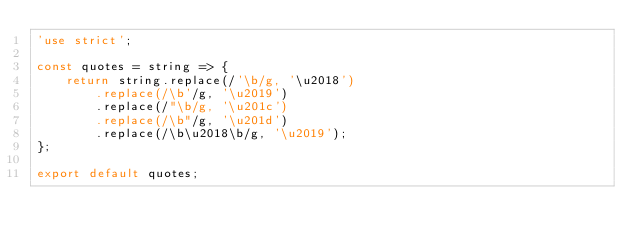<code> <loc_0><loc_0><loc_500><loc_500><_JavaScript_>'use strict';

const quotes = string => {
	return string.replace(/'\b/g, '\u2018')
		.replace(/\b'/g, '\u2019')
		.replace(/"\b/g, '\u201c')
		.replace(/\b"/g, '\u201d')
		.replace(/\b\u2018\b/g, '\u2019');
};

export default quotes;
</code> 